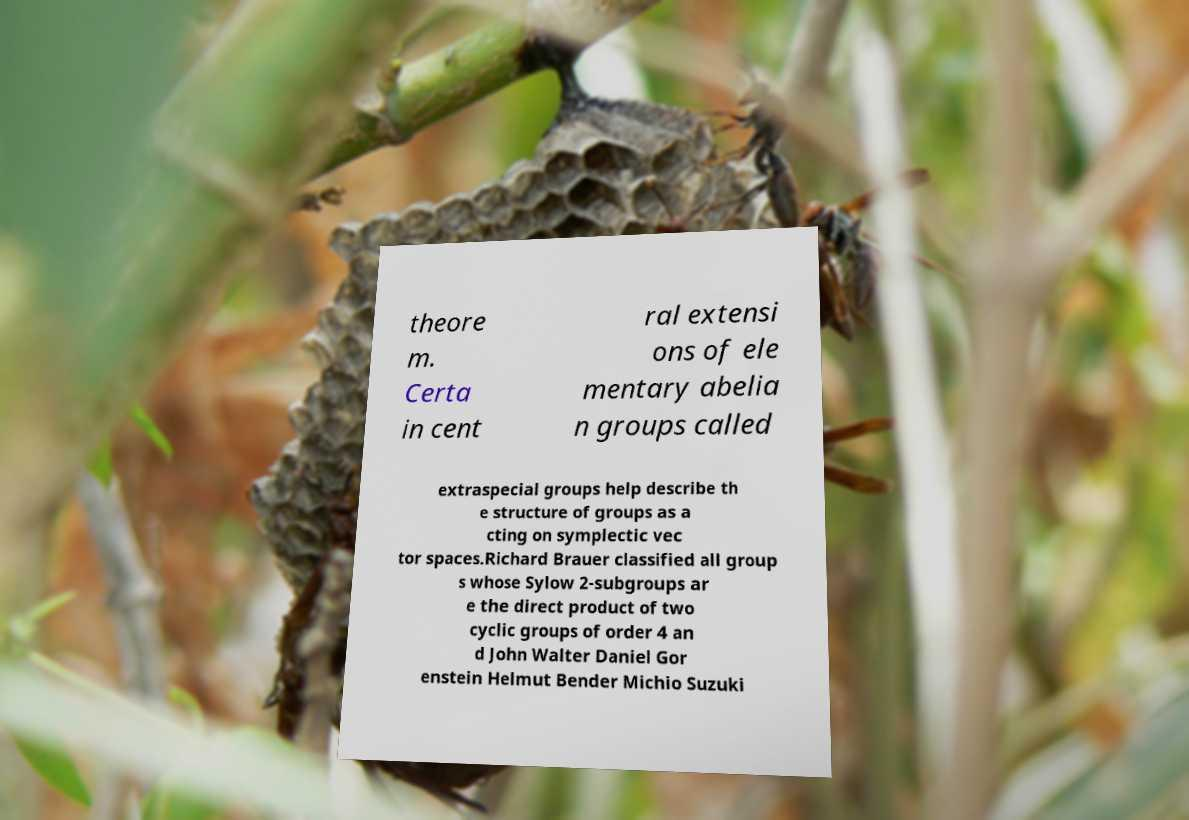Could you assist in decoding the text presented in this image and type it out clearly? theore m. Certa in cent ral extensi ons of ele mentary abelia n groups called extraspecial groups help describe th e structure of groups as a cting on symplectic vec tor spaces.Richard Brauer classified all group s whose Sylow 2-subgroups ar e the direct product of two cyclic groups of order 4 an d John Walter Daniel Gor enstein Helmut Bender Michio Suzuki 